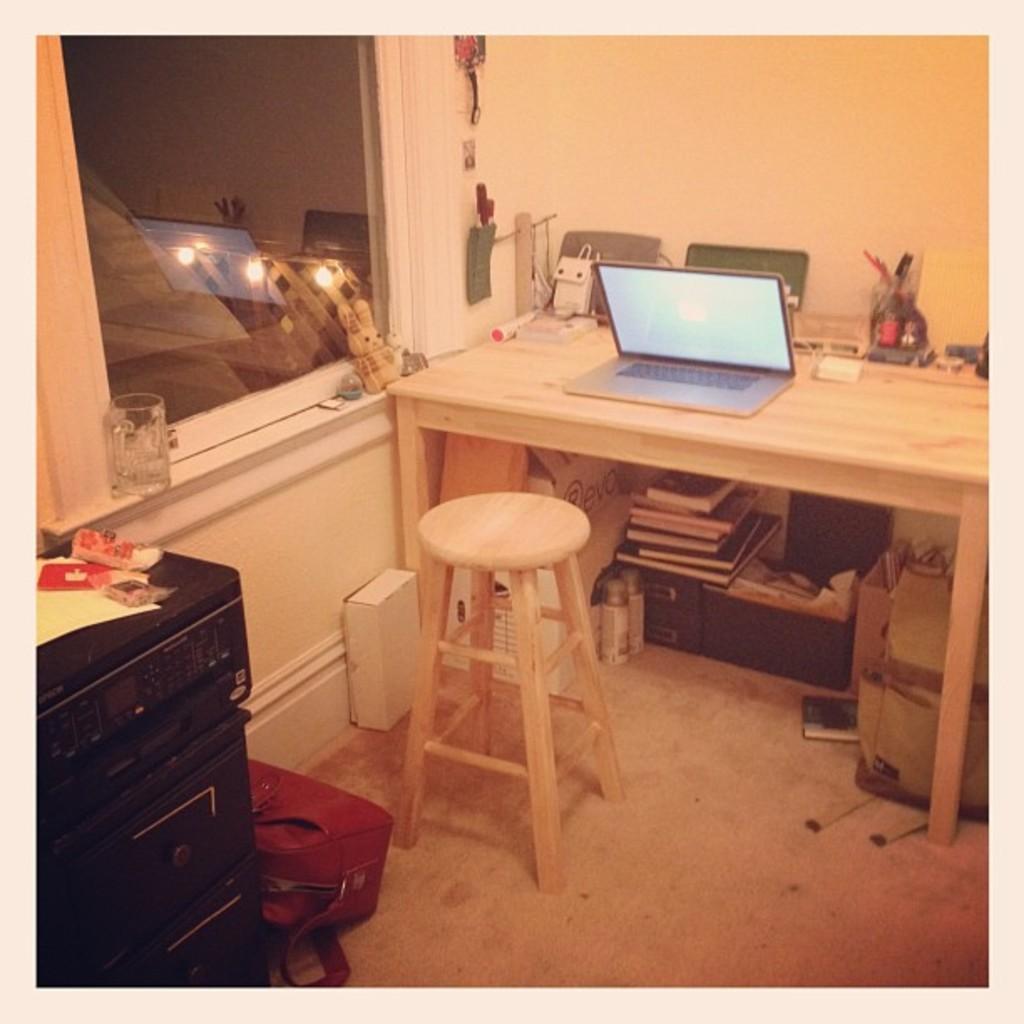In one or two sentences, can you explain what this image depicts? This is a wooden table with a laptop and some other objects placed on the table. This is a wooden stool which is in front of the table. I can see a small bag which is kept on the floor. There are few books,two bottles and other objects under the table. I can see a glass jug and a small toy which is kept near the window. There are some objects attached to the wall. This looks like an device which is kept aside and I can see small objects placed on the device. 